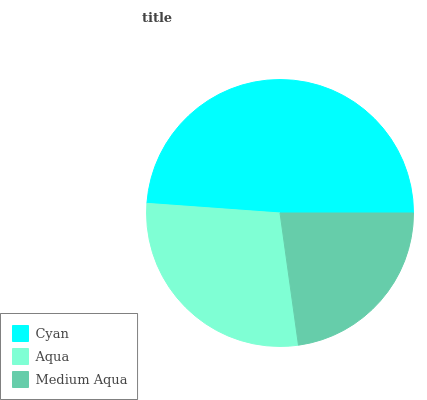Is Medium Aqua the minimum?
Answer yes or no. Yes. Is Cyan the maximum?
Answer yes or no. Yes. Is Aqua the minimum?
Answer yes or no. No. Is Aqua the maximum?
Answer yes or no. No. Is Cyan greater than Aqua?
Answer yes or no. Yes. Is Aqua less than Cyan?
Answer yes or no. Yes. Is Aqua greater than Cyan?
Answer yes or no. No. Is Cyan less than Aqua?
Answer yes or no. No. Is Aqua the high median?
Answer yes or no. Yes. Is Aqua the low median?
Answer yes or no. Yes. Is Cyan the high median?
Answer yes or no. No. Is Cyan the low median?
Answer yes or no. No. 